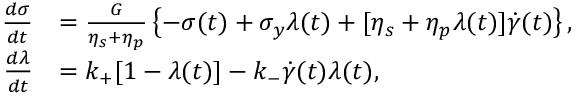<formula> <loc_0><loc_0><loc_500><loc_500>\begin{array} { r l } { \frac { d \sigma } { d t } } & { = \frac { G } { \eta _ { s } + \eta _ { p } } \left \{ - \sigma ( t ) + \sigma _ { y } \lambda ( t ) + [ \eta _ { s } + \eta _ { p } \lambda ( t ) ] \dot { \gamma } ( t ) \right \} , } \\ { \frac { d \lambda } { d t } } & { = k _ { + } [ 1 - \lambda ( t ) ] - k _ { - } \dot { \gamma } ( t ) \lambda ( t ) , } \end{array}</formula> 